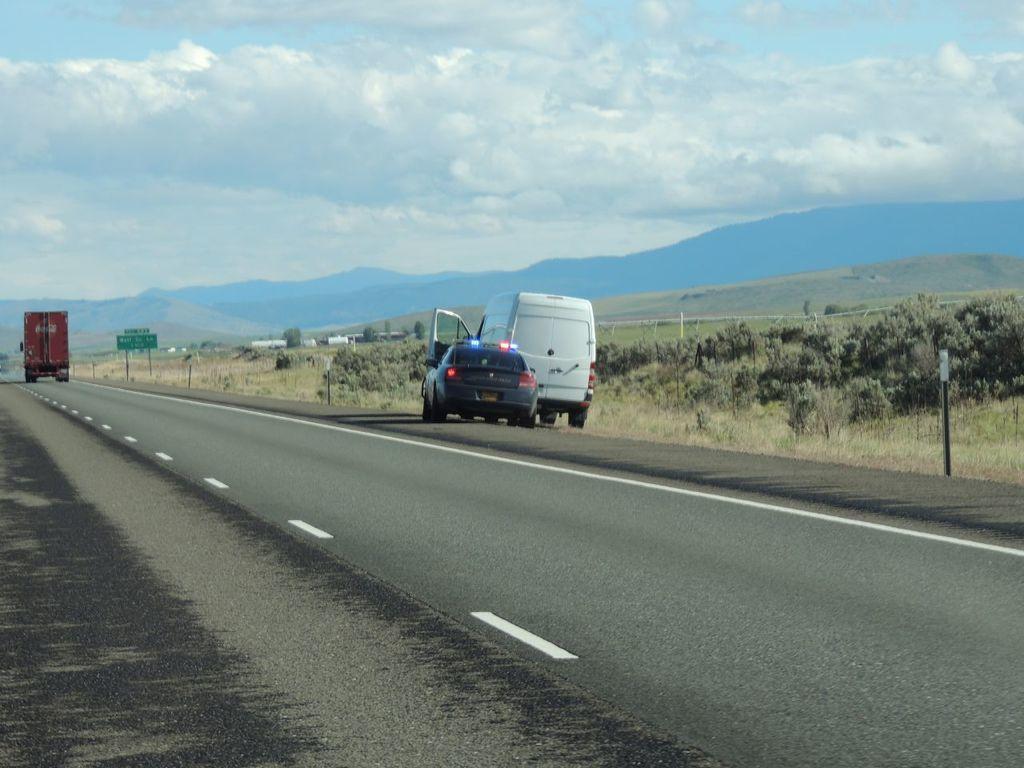Can you describe this image briefly? In this image there is a road and we can see vehicles on the road. In the background there are trees, hills and sky. We can see a board. 